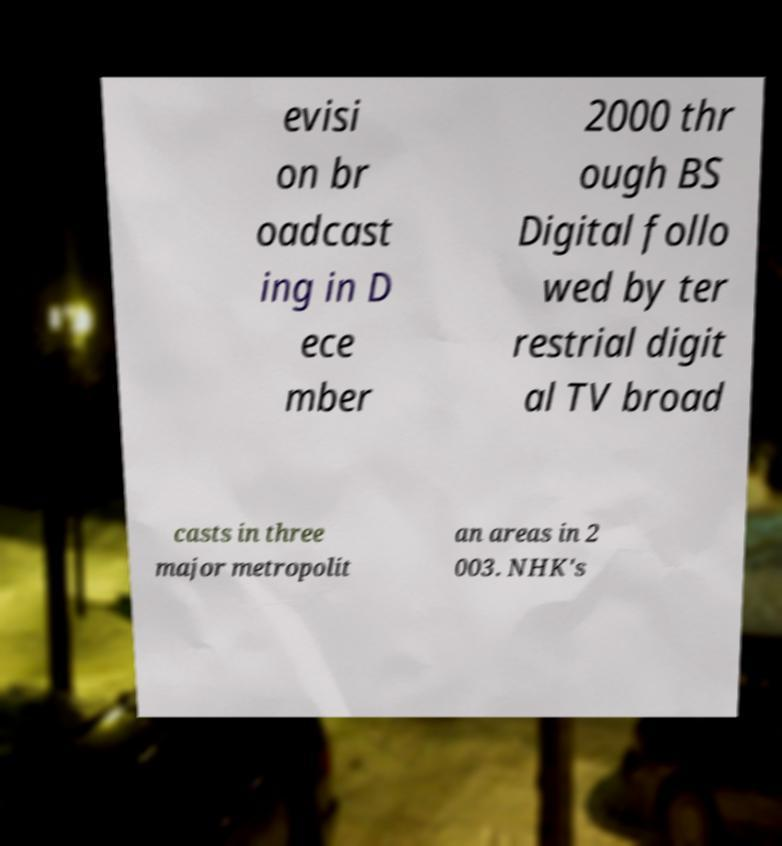Please read and relay the text visible in this image. What does it say? evisi on br oadcast ing in D ece mber 2000 thr ough BS Digital follo wed by ter restrial digit al TV broad casts in three major metropolit an areas in 2 003. NHK's 